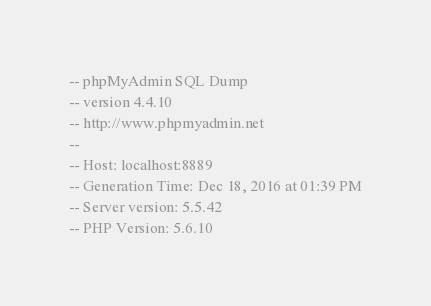<code> <loc_0><loc_0><loc_500><loc_500><_SQL_>-- phpMyAdmin SQL Dump
-- version 4.4.10
-- http://www.phpmyadmin.net
--
-- Host: localhost:8889
-- Generation Time: Dec 18, 2016 at 01:39 PM
-- Server version: 5.5.42
-- PHP Version: 5.6.10
</code> 